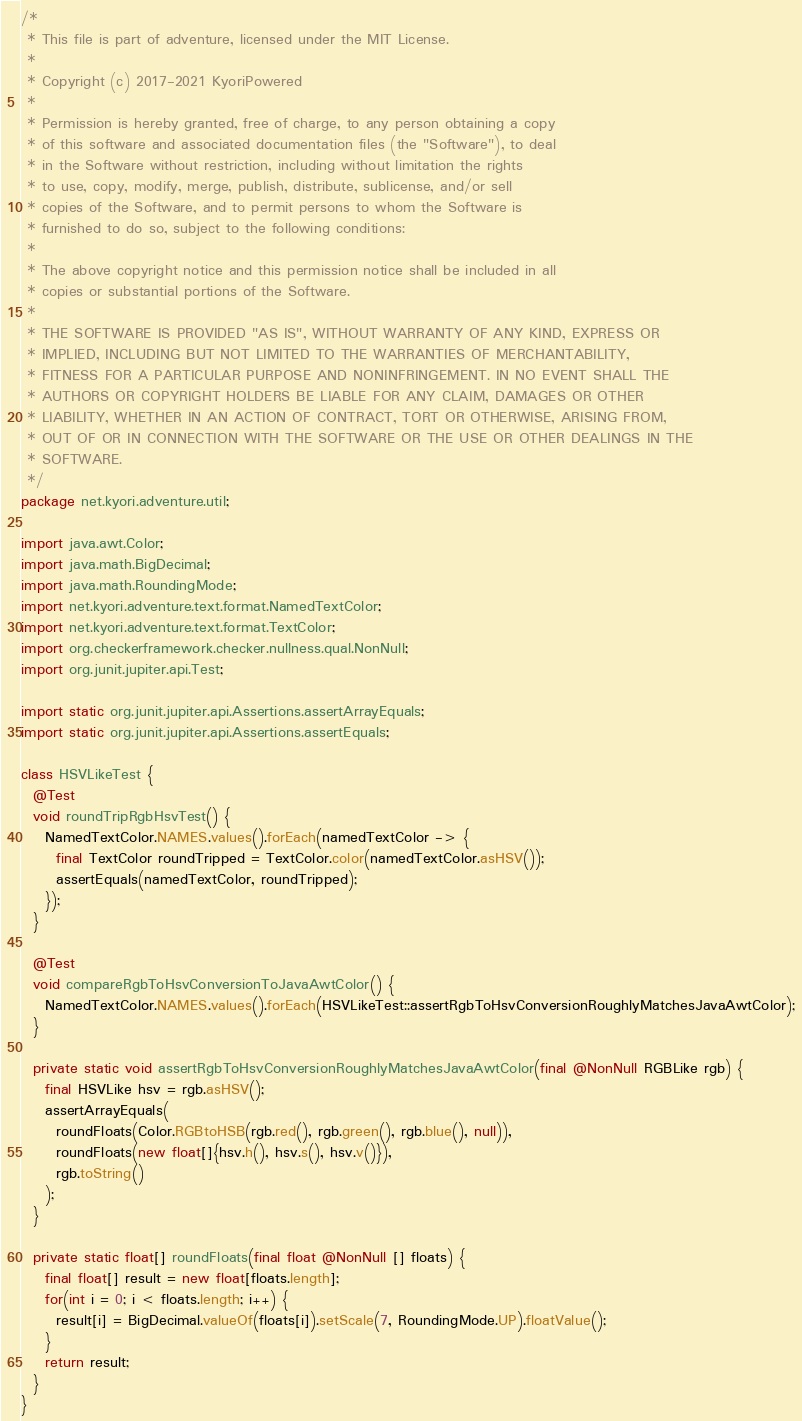<code> <loc_0><loc_0><loc_500><loc_500><_Java_>/*
 * This file is part of adventure, licensed under the MIT License.
 *
 * Copyright (c) 2017-2021 KyoriPowered
 *
 * Permission is hereby granted, free of charge, to any person obtaining a copy
 * of this software and associated documentation files (the "Software"), to deal
 * in the Software without restriction, including without limitation the rights
 * to use, copy, modify, merge, publish, distribute, sublicense, and/or sell
 * copies of the Software, and to permit persons to whom the Software is
 * furnished to do so, subject to the following conditions:
 *
 * The above copyright notice and this permission notice shall be included in all
 * copies or substantial portions of the Software.
 *
 * THE SOFTWARE IS PROVIDED "AS IS", WITHOUT WARRANTY OF ANY KIND, EXPRESS OR
 * IMPLIED, INCLUDING BUT NOT LIMITED TO THE WARRANTIES OF MERCHANTABILITY,
 * FITNESS FOR A PARTICULAR PURPOSE AND NONINFRINGEMENT. IN NO EVENT SHALL THE
 * AUTHORS OR COPYRIGHT HOLDERS BE LIABLE FOR ANY CLAIM, DAMAGES OR OTHER
 * LIABILITY, WHETHER IN AN ACTION OF CONTRACT, TORT OR OTHERWISE, ARISING FROM,
 * OUT OF OR IN CONNECTION WITH THE SOFTWARE OR THE USE OR OTHER DEALINGS IN THE
 * SOFTWARE.
 */
package net.kyori.adventure.util;

import java.awt.Color;
import java.math.BigDecimal;
import java.math.RoundingMode;
import net.kyori.adventure.text.format.NamedTextColor;
import net.kyori.adventure.text.format.TextColor;
import org.checkerframework.checker.nullness.qual.NonNull;
import org.junit.jupiter.api.Test;

import static org.junit.jupiter.api.Assertions.assertArrayEquals;
import static org.junit.jupiter.api.Assertions.assertEquals;

class HSVLikeTest {
  @Test
  void roundTripRgbHsvTest() {
    NamedTextColor.NAMES.values().forEach(namedTextColor -> {
      final TextColor roundTripped = TextColor.color(namedTextColor.asHSV());
      assertEquals(namedTextColor, roundTripped);
    });
  }

  @Test
  void compareRgbToHsvConversionToJavaAwtColor() {
    NamedTextColor.NAMES.values().forEach(HSVLikeTest::assertRgbToHsvConversionRoughlyMatchesJavaAwtColor);
  }

  private static void assertRgbToHsvConversionRoughlyMatchesJavaAwtColor(final @NonNull RGBLike rgb) {
    final HSVLike hsv = rgb.asHSV();
    assertArrayEquals(
      roundFloats(Color.RGBtoHSB(rgb.red(), rgb.green(), rgb.blue(), null)),
      roundFloats(new float[]{hsv.h(), hsv.s(), hsv.v()}),
      rgb.toString()
    );
  }

  private static float[] roundFloats(final float @NonNull [] floats) {
    final float[] result = new float[floats.length];
    for(int i = 0; i < floats.length; i++) {
      result[i] = BigDecimal.valueOf(floats[i]).setScale(7, RoundingMode.UP).floatValue();
    }
    return result;
  }
}
</code> 